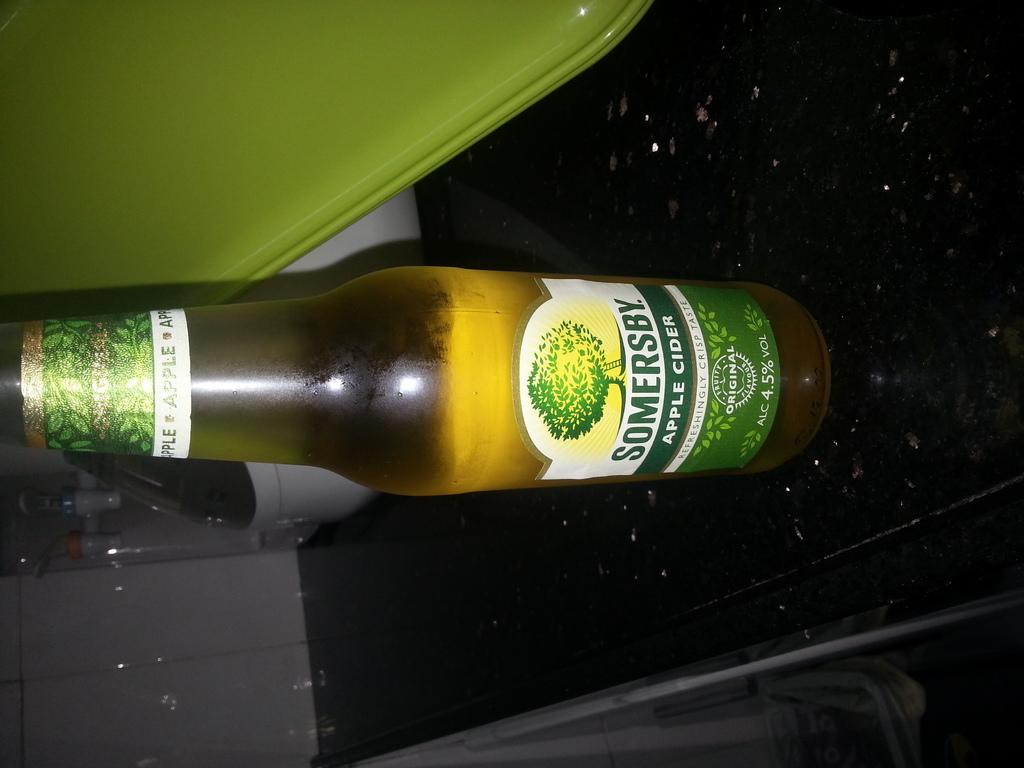Provide a one-sentence caption for the provided image. A bottle of apple cider, made by Somersby, is on a table. 